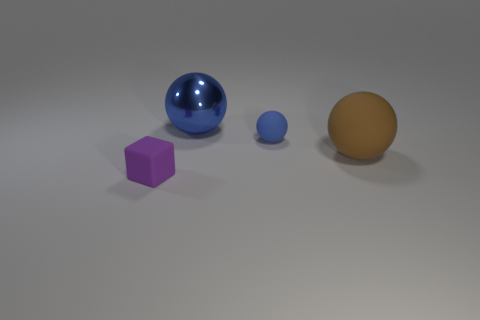What could the different sizes and colors of these objects represent if this were an art installation? If interpreted as an art installation, the varied sizes and colors of these objects could symbolize diversity and individuality within a community. The isolation of each object might represent personal space or the unique role each individual plays. The shiny blue sphere's reflective surface invites viewers to see themselves in the context of this arrangement, possibly urging a contemplation of one's own place in society. 